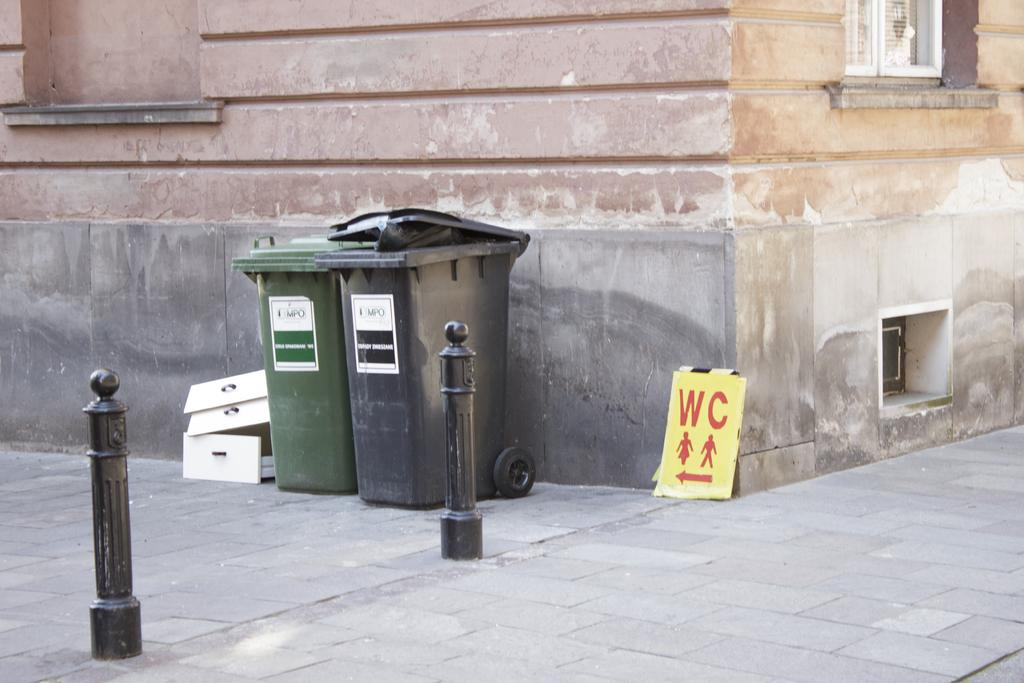<image>
Render a clear and concise summary of the photo. Garbage bins outdoors next to a sign which says WC. 